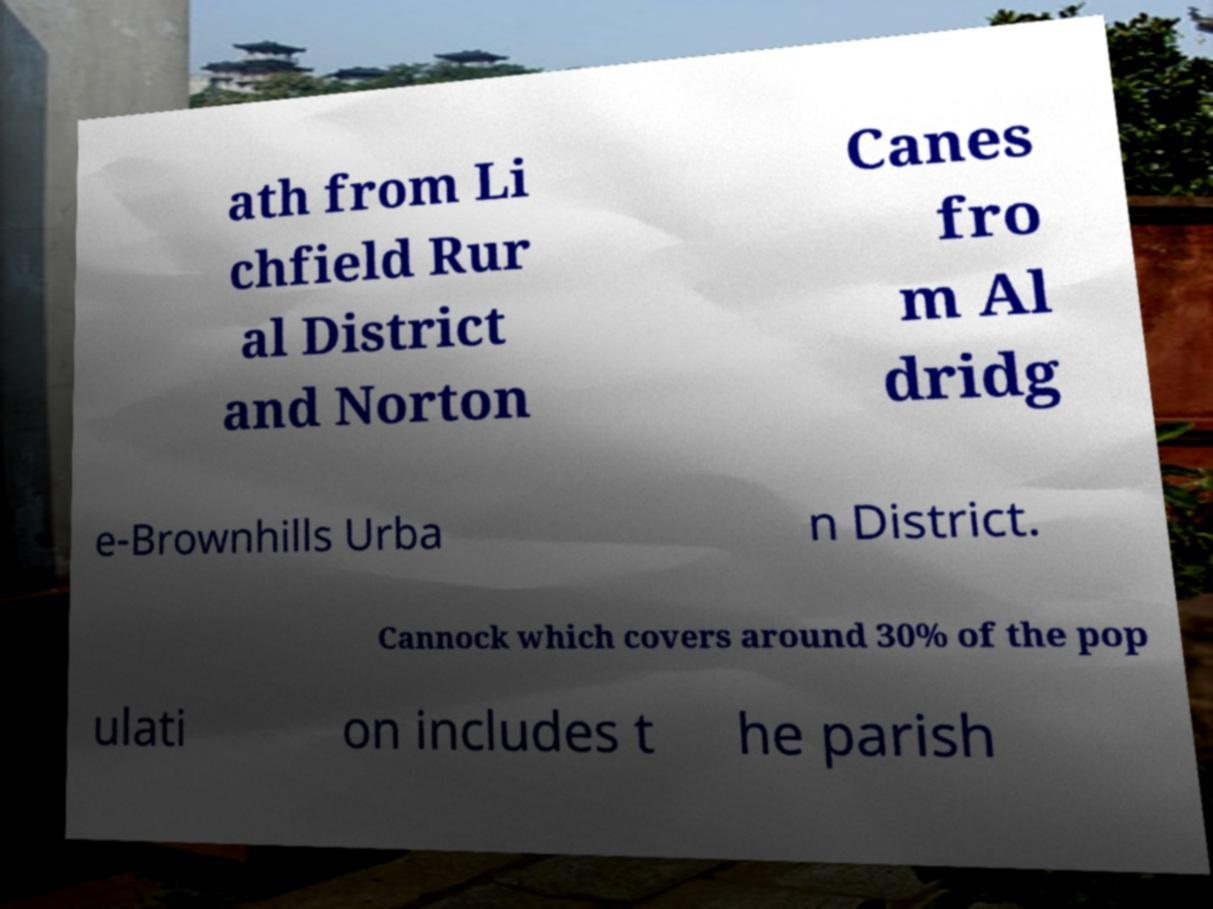Could you extract and type out the text from this image? ath from Li chfield Rur al District and Norton Canes fro m Al dridg e-Brownhills Urba n District. Cannock which covers around 30% of the pop ulati on includes t he parish 